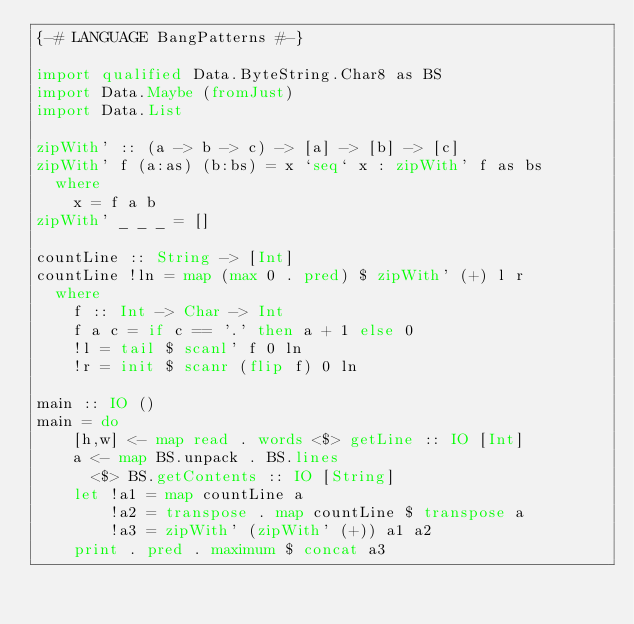<code> <loc_0><loc_0><loc_500><loc_500><_Haskell_>{-# LANGUAGE BangPatterns #-}

import qualified Data.ByteString.Char8 as BS
import Data.Maybe (fromJust)
import Data.List

zipWith' :: (a -> b -> c) -> [a] -> [b] -> [c]
zipWith' f (a:as) (b:bs) = x `seq` x : zipWith' f as bs
  where
    x = f a b
zipWith' _ _ _ = []

countLine :: String -> [Int]
countLine !ln = map (max 0 . pred) $ zipWith' (+) l r
  where
    f :: Int -> Char -> Int
    f a c = if c == '.' then a + 1 else 0
    !l = tail $ scanl' f 0 ln
    !r = init $ scanr (flip f) 0 ln

main :: IO ()
main = do
    [h,w] <- map read . words <$> getLine :: IO [Int]
    a <- map BS.unpack . BS.lines
      <$> BS.getContents :: IO [String]
    let !a1 = map countLine a
        !a2 = transpose . map countLine $ transpose a
        !a3 = zipWith' (zipWith' (+)) a1 a2
    print . pred . maximum $ concat a3 
</code> 